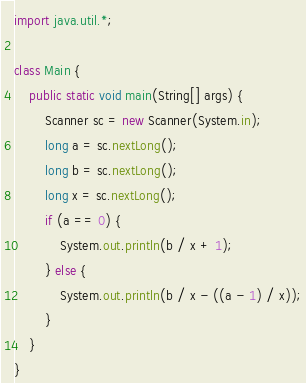<code> <loc_0><loc_0><loc_500><loc_500><_Java_>import java.util.*;

class Main {
    public static void main(String[] args) {
        Scanner sc = new Scanner(System.in);
        long a = sc.nextLong();
        long b = sc.nextLong();
        long x = sc.nextLong();
        if (a == 0) {
            System.out.println(b / x + 1);
        } else {
            System.out.println(b / x - ((a - 1) / x));
        }
    }
}</code> 